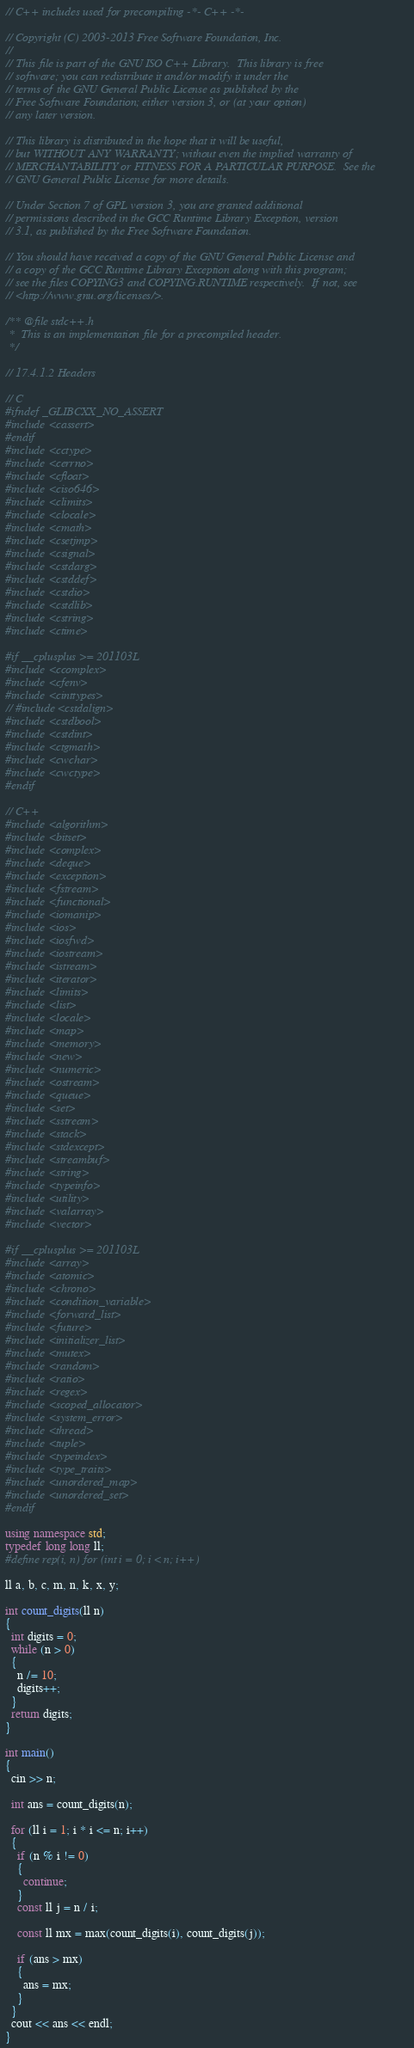<code> <loc_0><loc_0><loc_500><loc_500><_C++_>// C++ includes used for precompiling -*- C++ -*-

// Copyright (C) 2003-2013 Free Software Foundation, Inc.
//
// This file is part of the GNU ISO C++ Library.  This library is free
// software; you can redistribute it and/or modify it under the
// terms of the GNU General Public License as published by the
// Free Software Foundation; either version 3, or (at your option)
// any later version.

// This library is distributed in the hope that it will be useful,
// but WITHOUT ANY WARRANTY; without even the implied warranty of
// MERCHANTABILITY or FITNESS FOR A PARTICULAR PURPOSE.  See the
// GNU General Public License for more details.

// Under Section 7 of GPL version 3, you are granted additional
// permissions described in the GCC Runtime Library Exception, version
// 3.1, as published by the Free Software Foundation.

// You should have received a copy of the GNU General Public License and
// a copy of the GCC Runtime Library Exception along with this program;
// see the files COPYING3 and COPYING.RUNTIME respectively.  If not, see
// <http://www.gnu.org/licenses/>.

/** @file stdc++.h
 *  This is an implementation file for a precompiled header.
 */

// 17.4.1.2 Headers

// C
#ifndef _GLIBCXX_NO_ASSERT
#include <cassert>
#endif
#include <cctype>
#include <cerrno>
#include <cfloat>
#include <ciso646>
#include <climits>
#include <clocale>
#include <cmath>
#include <csetjmp>
#include <csignal>
#include <cstdarg>
#include <cstddef>
#include <cstdio>
#include <cstdlib>
#include <cstring>
#include <ctime>

#if __cplusplus >= 201103L
#include <ccomplex>
#include <cfenv>
#include <cinttypes>
// #include <cstdalign>
#include <cstdbool>
#include <cstdint>
#include <ctgmath>
#include <cwchar>
#include <cwctype>
#endif

// C++
#include <algorithm>
#include <bitset>
#include <complex>
#include <deque>
#include <exception>
#include <fstream>
#include <functional>
#include <iomanip>
#include <ios>
#include <iosfwd>
#include <iostream>
#include <istream>
#include <iterator>
#include <limits>
#include <list>
#include <locale>
#include <map>
#include <memory>
#include <new>
#include <numeric>
#include <ostream>
#include <queue>
#include <set>
#include <sstream>
#include <stack>
#include <stdexcept>
#include <streambuf>
#include <string>
#include <typeinfo>
#include <utility>
#include <valarray>
#include <vector>

#if __cplusplus >= 201103L
#include <array>
#include <atomic>
#include <chrono>
#include <condition_variable>
#include <forward_list>
#include <future>
#include <initializer_list>
#include <mutex>
#include <random>
#include <ratio>
#include <regex>
#include <scoped_allocator>
#include <system_error>
#include <thread>
#include <tuple>
#include <typeindex>
#include <type_traits>
#include <unordered_map>
#include <unordered_set>
#endif

using namespace std;
typedef long long ll;
#define rep(i, n) for (int i = 0; i < n; i++)

ll a, b, c, m, n, k, x, y;

int count_digits(ll n)
{
  int digits = 0;
  while (n > 0)
  {
    n /= 10;
    digits++;
  }
  return digits;
}

int main()
{
  cin >> n;

  int ans = count_digits(n);

  for (ll i = 1; i * i <= n; i++)
  {
    if (n % i != 0)
    {
      continue;
    }
    const ll j = n / i;

    const ll mx = max(count_digits(i), count_digits(j));

    if (ans > mx)
    {
      ans = mx;
    }
  }
  cout << ans << endl;
}
</code> 